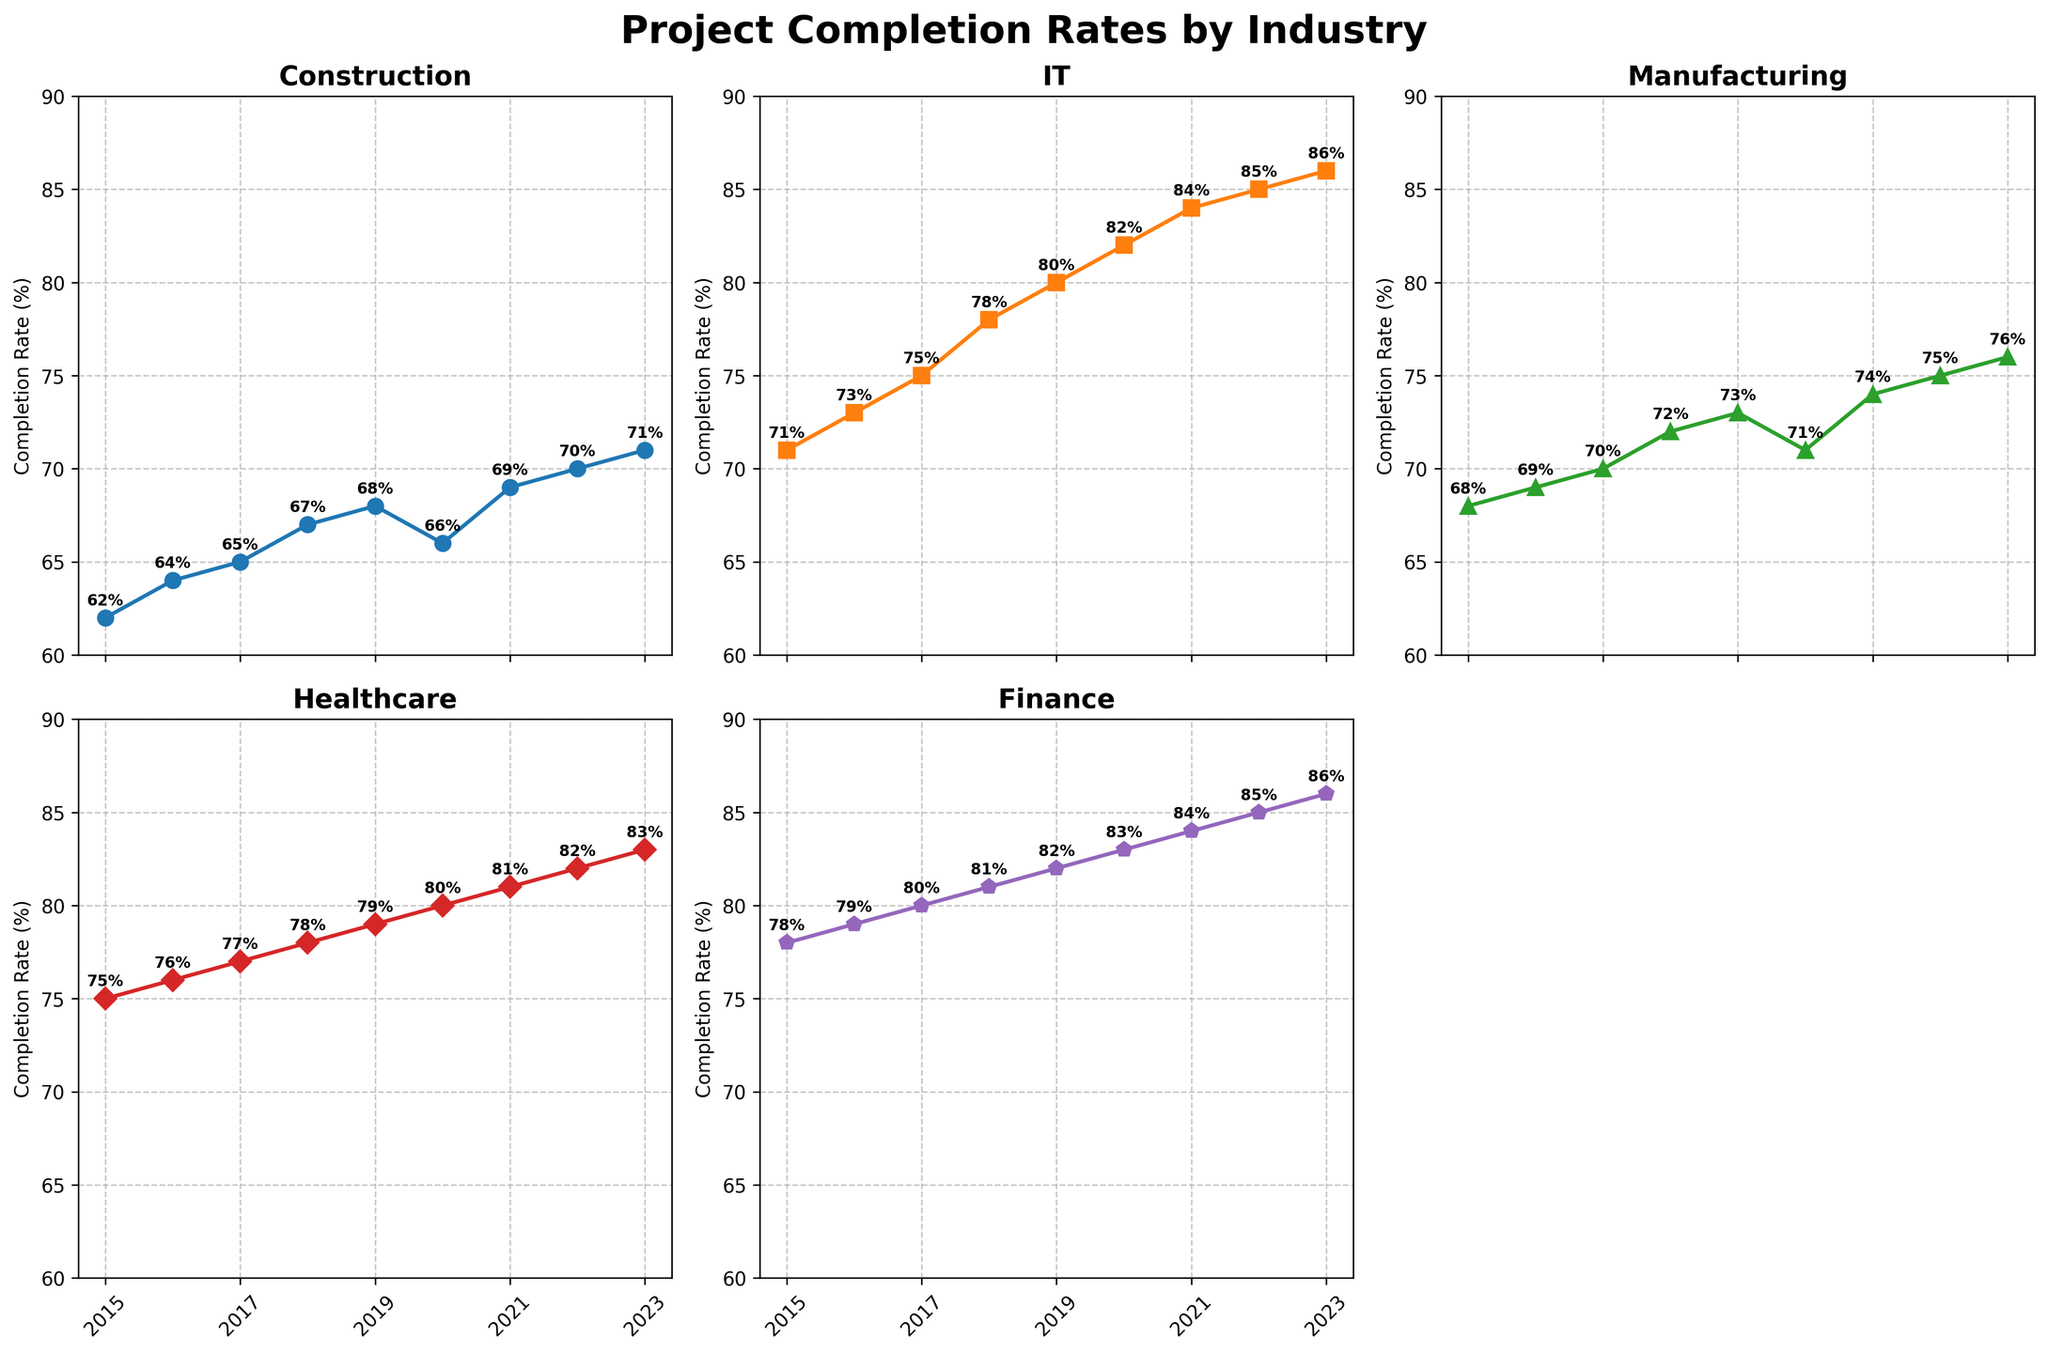Which industry had the highest project completion rate in 2017? Look at the subplot for each industry and find the completion rates in 2017. Compare them to find the highest. The highest rate in 2017 is for Finance, with 80%.
Answer: Finance What is the average project completion rate for IT from 2015 to 2023? Add the yearly completion rates for IT from 2015 to 2023 and divide by the number of years. (71+73+75+78+80+82+84+85+86)/9 = 79.33%
Answer: 79.33% How did the project completion rate for Healthcare change from 2020 to 2023? Compare the completion rates for Healthcare between 2020 and 2023. The rate increased from 80% to 83%, showing an upward trend.
Answer: Increased Which industry had the largest increase in project completion rate from 2016 to 2017? Calculate the difference in completion rates for each industry between 2016 and 2017. The largest increase is for IT, with a 2% increase (75% - 73%).
Answer: IT In which year did Manufacturing have its lowest project completion rate? Review the subplot for Manufacturing and find the lowest value across the years. The lowest rate is in 2020, at 71%.
Answer: 2020 What is the difference in project completion rates between Construction and Finance in 2023? Subtract the completion rate of Construction from Finance in 2023. 86% - 71% = 15%
Answer: 15% How does the project completion trend for Finance compare to Construction from 2015 to 2023? Compare the slopes of the lines for Finance and Construction. Finance shows a steady increase from 78% to 86%, whereas Construction has a slower increase from 62% to 71%.
Answer: Finance has a steeper increasing trend Which year saw the highlight of project completion rate for Healthcare? Look for the highest project completion rate in the Healthcare subplot. The highest value is in 2023 at 83%.
Answer: 2023 By how much did the project completion rate for IT increase from 2015 to 2023? Subtract the value of IT in 2015 from the value in 2023. 86% - 71% = 15%
Answer: 15% 